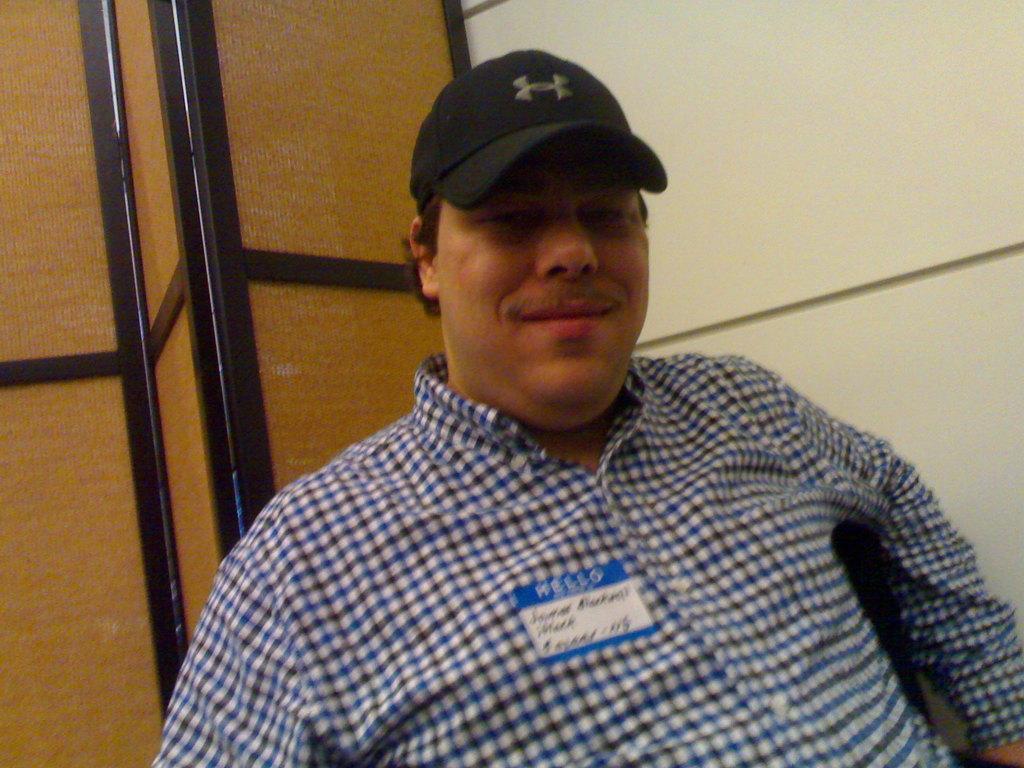How would you summarize this image in a sentence or two? In this picture there is a man sitting in the front, smiling and giving a pose. Behind there is a yellow color wall and brown doors. 